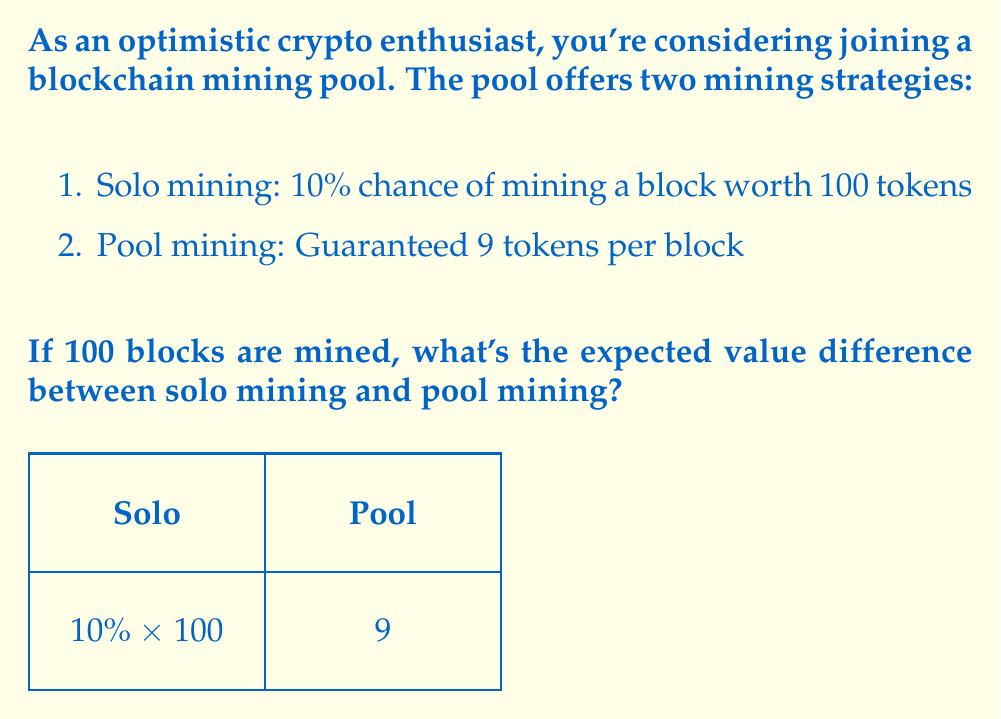Can you answer this question? Let's approach this step-by-step:

1) First, let's calculate the expected value of solo mining for one block:
   $EV_{solo} = 0.10 \times 100 + 0.90 \times 0 = 10$ tokens

2) For pool mining, the expected value is simply the guaranteed amount:
   $EV_{pool} = 9$ tokens

3) The difference in expected value per block is:
   $EV_{diff} = EV_{solo} - EV_{pool} = 10 - 9 = 1$ token

4) For 100 blocks, we multiply this difference by 100:
   $EV_{total\_diff} = 100 \times EV_{diff} = 100 \times 1 = 100$ tokens

5) Therefore, over 100 blocks, the expected value of solo mining is 100 tokens higher than pool mining.

As an optimistic crypto enthusiast, you might view this as an exciting opportunity to potentially earn more through solo mining, while also appreciating the steady returns of pool mining as a reliable alternative.
Answer: 100 tokens 